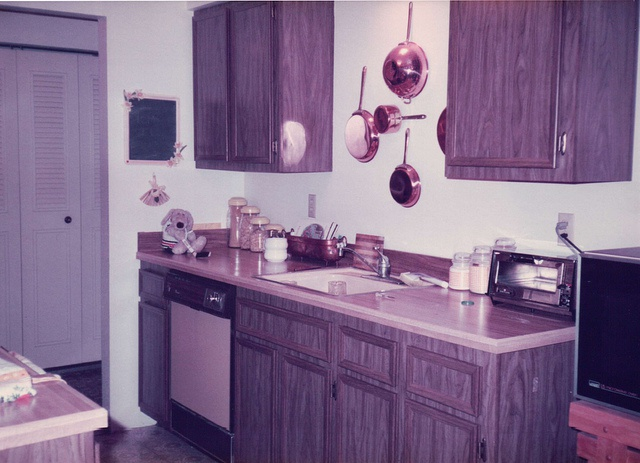Describe the objects in this image and their specific colors. I can see oven in white, navy, gray, and purple tones, microwave in white, navy, and purple tones, microwave in white, navy, purple, and lightgray tones, sink in white, pink, lightgray, and lightpink tones, and cup in white, lightgray, darkgray, and pink tones in this image. 